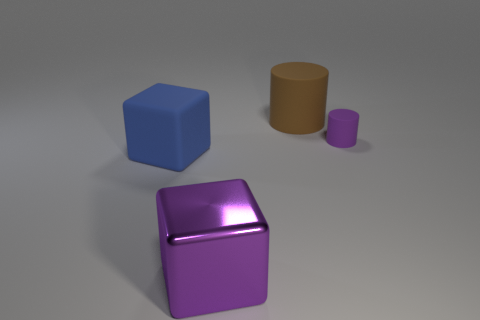The purple cylinder that is the same material as the large brown cylinder is what size?
Offer a very short reply. Small. Are there any big blue objects on the right side of the big brown thing?
Offer a terse response. No. There is another object that is the same shape as the small purple object; what is its size?
Give a very brief answer. Large. There is a big rubber cylinder; is its color the same as the matte cylinder in front of the brown rubber thing?
Provide a short and direct response. No. Is the color of the tiny rubber cylinder the same as the large rubber cube?
Ensure brevity in your answer.  No. Is the number of brown cylinders less than the number of big red cylinders?
Your answer should be very brief. No. How many other things are there of the same color as the big matte block?
Offer a very short reply. 0. What number of small cylinders are there?
Your answer should be very brief. 1. Are there fewer large blue blocks that are to the right of the blue matte cube than tiny green shiny objects?
Make the answer very short. No. Do the large thing behind the tiny object and the blue thing have the same material?
Provide a succinct answer. Yes. 